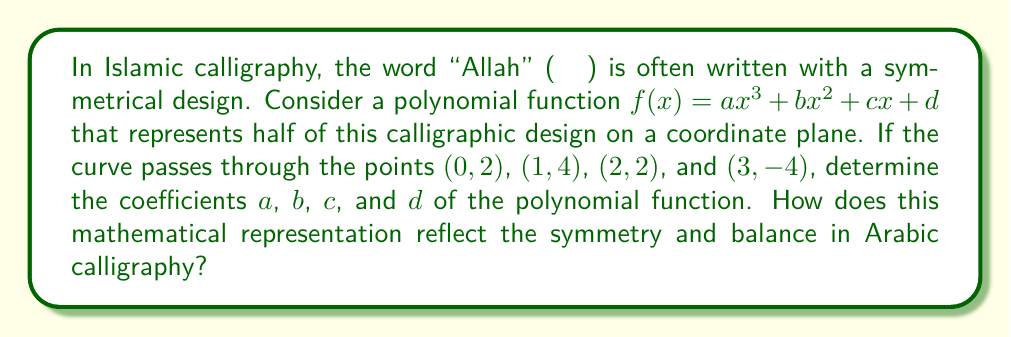Could you help me with this problem? Let's approach this step-by-step:

1) We have the general form of the polynomial: $f(x) = ax^3 + bx^2 + cx + d$

2) We know four points that the curve passes through:
   (0, 2), (1, 4), (2, 2), and (3, -4)

3) Let's substitute these points into the general equation:

   For (0, 2): $2 = a(0)^3 + b(0)^2 + c(0) + d$, simplifies to $2 = d$
   For (1, 4): $4 = a(1)^3 + b(1)^2 + c(1) + d$, or $4 = a + b + c + 2$
   For (2, 2): $2 = a(2)^3 + b(2)^2 + c(2) + d$, or $2 = 8a + 4b + 2c + 2$
   For (3, -4): $-4 = a(3)^3 + b(3)^2 + c(3) + d$, or $-4 = 27a + 9b + 3c + 2$

4) From the first equation, we know that $d = 2$

5) Subtracting the first equation from the others:

   $2 = a + b + c$
   $0 = 8a + 4b + 2c$
   $-6 = 27a + 9b + 3c$

6) Multiply the second equation by -1 and the third by -1/3:

   $2 = a + b + c$
   $0 = -8a - 4b - 2c$
   $2 = -9a - 3b - c$

7) Add these equations:

   $4 = -16a - 6b - 2c$

8) Substitute $c = 2 - a - b$ from the first equation:

   $4 = -16a - 6b - 2(2 - a - b)$
   $4 = -16a - 6b - 4 + 2a + 2b$
   $8 = -14a - 4b$
   $2 = -\frac{7}{2}a - b$

9) Substitute this back into $2 = a + b + c$:

   $2 = a + (-\frac{7}{2}a - 2) + c$
   $4 = -\frac{5}{2}a + c$
   $c = 4 + \frac{5}{2}a$

10) Substitute these into the original equation:

    $-4 = 27a + 9(-\frac{7}{2}a - 2) + 3(4 + \frac{5}{2}a) + 2$
    $-4 = 27a - \frac{63}{2}a - 18 + 12 + \frac{15}{2}a + 2$
    $0 = 27a - \frac{63}{2}a + \frac{15}{2}a - 8$
    $0 = 54a - 63a + 15a - 16$
    $0 = 6a - 16$
    $a = \frac{8}{3}$

11) Now we can find $b$ and $c$:

    $b = -\frac{7}{2}a - 2 = -\frac{7}{2}(\frac{8}{3}) - 2 = -\frac{28}{6} - 2 = -\frac{40}{6} = -\frac{20}{3}$
    $c = 4 + \frac{5}{2}a = 4 + \frac{5}{2}(\frac{8}{3}) = 4 + \frac{20}{3} = \frac{32}{3}$

This polynomial representation reflects the symmetry and balance in Arabic calligraphy by creating a smooth, curved shape that rises and falls in a balanced manner, much like the flowing lines of calligraphic script. The coefficients ensure that the curve passes through specific points that could represent key features of the calligraphic design.
Answer: $a = \frac{8}{3}$, $b = -\frac{20}{3}$, $c = \frac{32}{3}$, $d = 2$ 